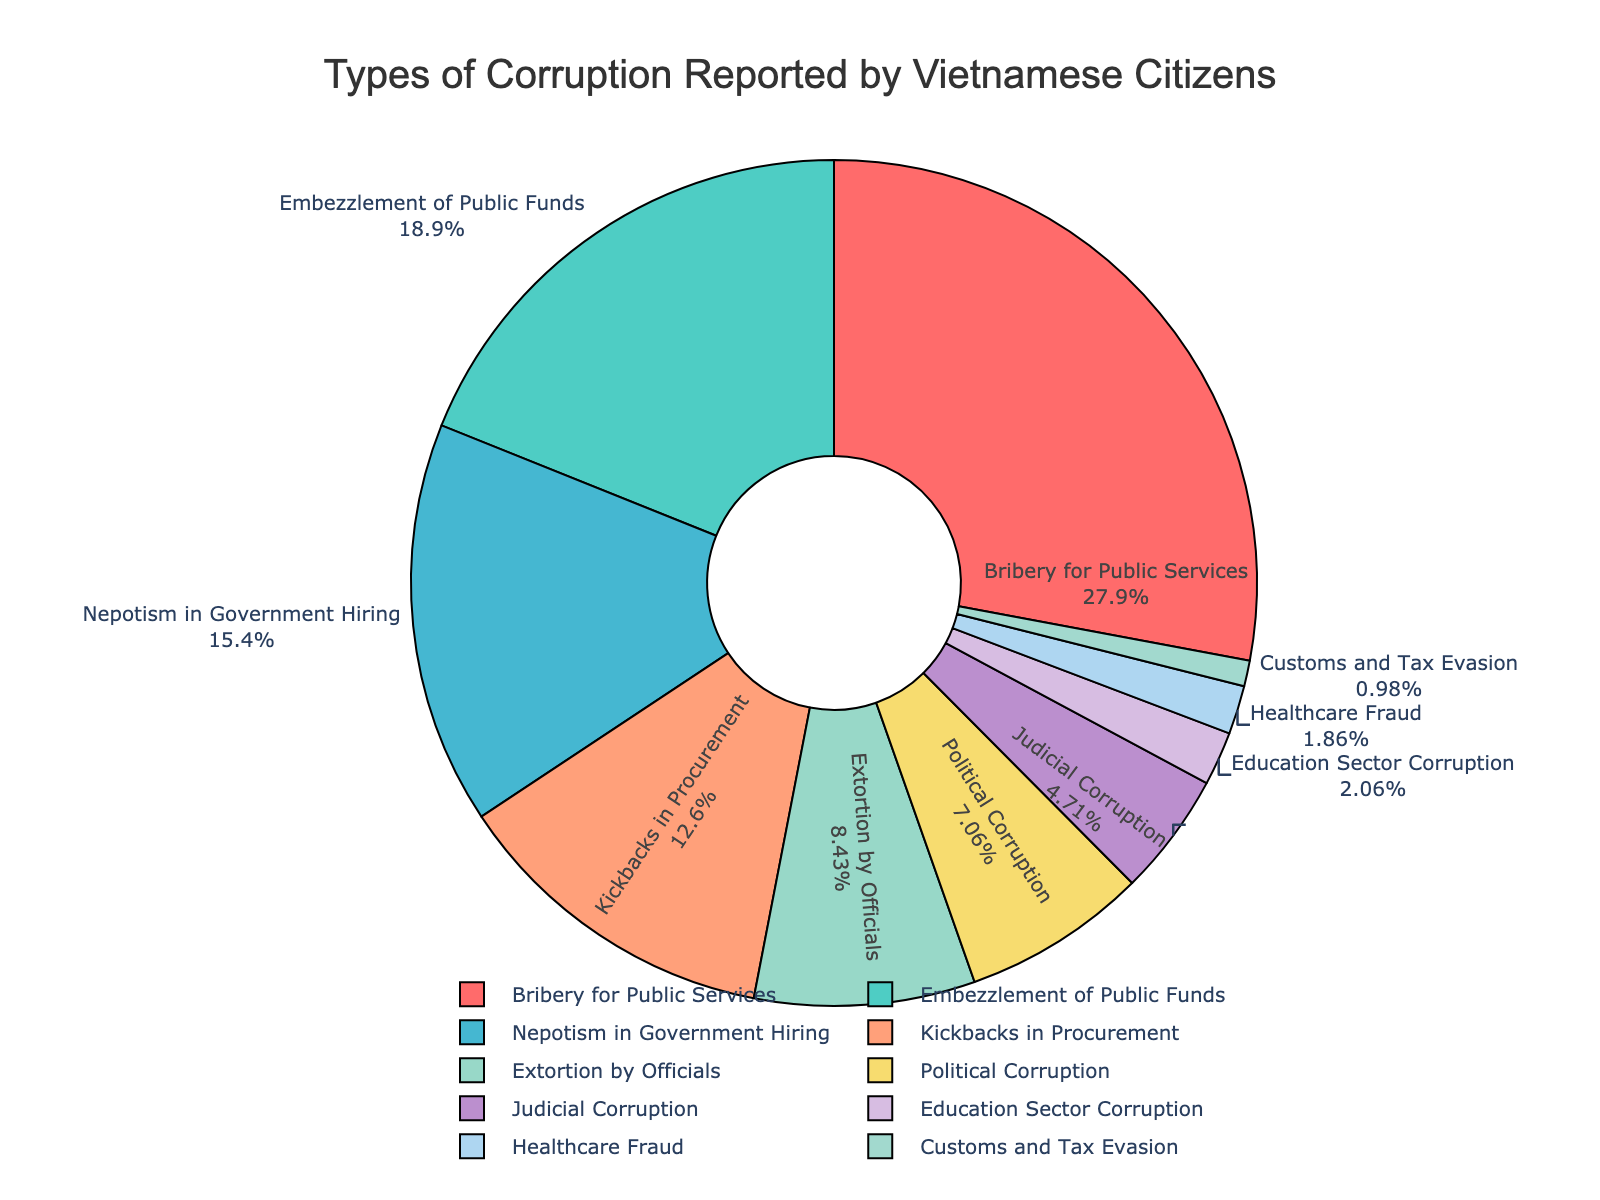What type of corruption is reported most frequently? The pie chart shows the different types of corruption and their respective percentages. The largest segment will indicate the most frequently reported type. "Bribery for Public Services" occupies the largest segment at 28.5%.
Answer: Bribery for Public Services Which type of corruption is reported least frequently? The smallest segment in the pie chart represents the least frequently reported type. "Customs and Tax Evasion" has the smallest segment at 1.0%.
Answer: Customs and Tax Evasion What is the combined percentage of Embezzlement of Public Funds and Nepotism in Government Hiring? To find the combined percentage, sum the individual percentages. Embezzlement of Public Funds is 19.3%, and Nepotism in Government Hiring is 15.7%. Thus, 19.3% + 15.7% = 35.0%.
Answer: 35.0% How much more prevalent is Bribery for Public Services compared to Political Corruption? Calculate the difference between the percentages of Bribery for Public Services and Political Corruption. Bribery for Public Services is 28.5%, and Political Corruption is 7.2%. The difference is 28.5% - 7.2% = 21.3%.
Answer: 21.3% Which types of corruption have a combined percentage greater than 40%? Sum the percentages of different corruptions until the total exceeds 40%. Embezzlement of Public Funds (19.3%) and Nepotism in Government Hiring (15.7%) together equal 35.0%. Adding Kickbacks in Procurement (12.9%) makes 35.0% + 12.9% = 47.9%, which is greater than 40%.
Answer: Embezzlement of Public Funds, Nepotism in Government Hiring, and Kickbacks in Procurement Is the percentage of Judicial Corruption greater or lesser than Extortion by Officials? Compare the percentages directly. Judicial Corruption is 4.8%, and Extortion by Officials is 8.6%. 4.8% is less than 8.6%.
Answer: Lesser What is the percentage difference between Nepotism in Government Hiring and Healthcare Fraud? Subtract the smaller percentage from the larger one. Nepotism in Government Hiring is 15.7%, and Healthcare Fraud is 1.9%. The difference is 15.7% - 1.9% = 13.8%.
Answer: 13.8% Which types of corruption combined make up less than 10%? Sum the percentages of different types until the total is less than 10%. Judicial Corruption (4.8%), Education Sector Corruption (2.1%), Healthcare Fraud (1.9%), and Customs and Tax Evasion (1.0%) together equal 4.8% + 2.1% + 1.9% + 1.0% = 9.8%.
Answer: Judicial Corruption, Education Sector Corruption, Healthcare Fraud, and Customs and Tax Evasion 